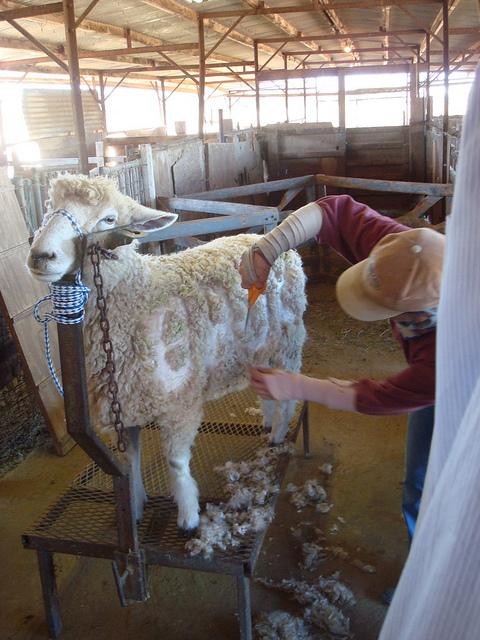What color is the sheep?
Keep it brief. White. Is the guy a sheep shearer?
Write a very short answer. Yes. Can the sheep roam freely?
Write a very short answer. No. 